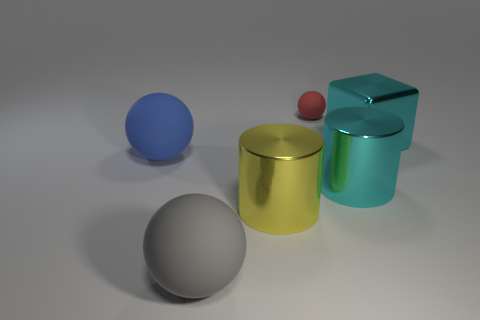Are the big blue object that is behind the big gray rubber thing and the small thing made of the same material?
Your response must be concise. Yes. What size is the metal cylinder to the right of the tiny red rubber object to the left of the shiny cylinder that is to the right of the small red matte thing?
Provide a succinct answer. Large. What number of other objects are there of the same color as the block?
Your answer should be very brief. 1. There is a blue object that is the same size as the gray sphere; what shape is it?
Provide a short and direct response. Sphere. There is a metal cylinder that is to the left of the tiny matte thing; what size is it?
Your response must be concise. Large. There is a object on the right side of the cyan cylinder; is it the same color as the large ball in front of the blue ball?
Make the answer very short. No. What material is the red object left of the metallic cylinder behind the metal thing that is on the left side of the cyan cylinder?
Offer a terse response. Rubber. Is there a purple ball of the same size as the yellow metallic cylinder?
Ensure brevity in your answer.  No. There is a yellow cylinder that is the same size as the gray ball; what is its material?
Your answer should be very brief. Metal. What is the shape of the large metal thing on the left side of the red ball?
Ensure brevity in your answer.  Cylinder. 